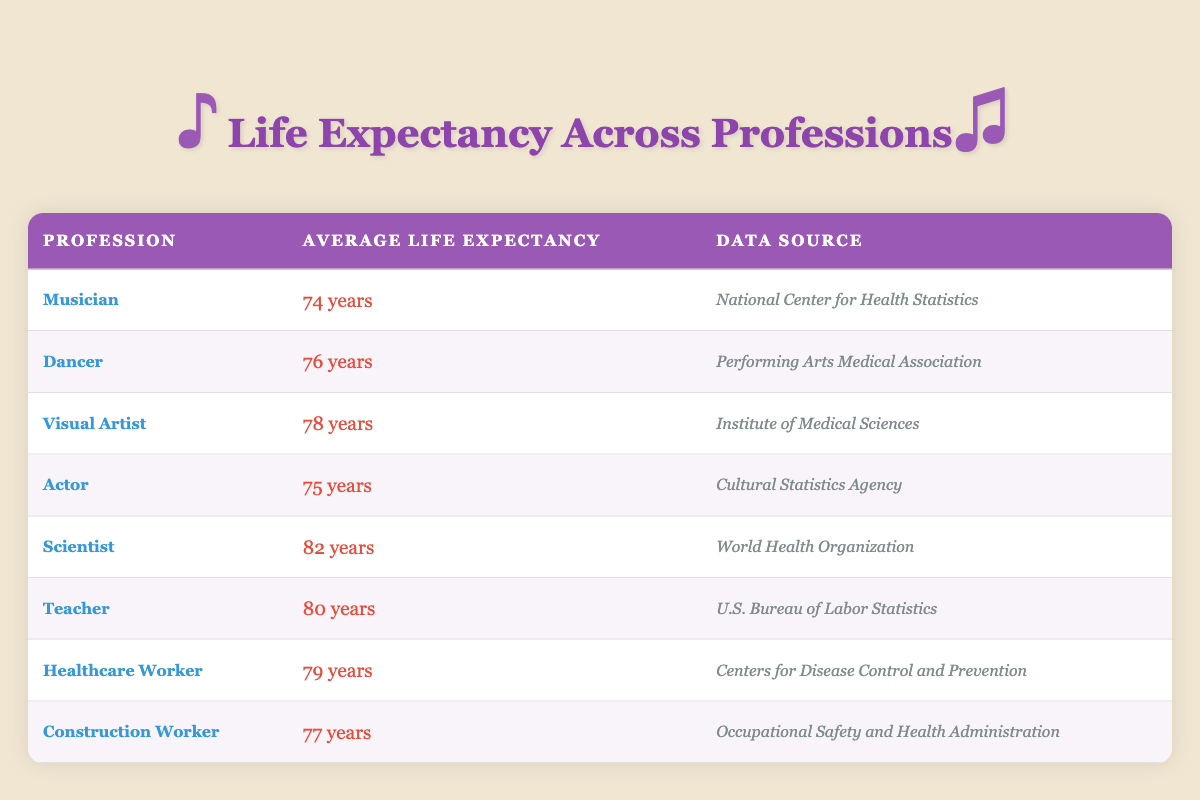What is the average life expectancy for dancers? The table lists the average life expectancy for dancers as 76 years. This information is found in the row corresponding to the profession "Dancer."
Answer: 76 years Which profession has the highest average life expectancy? Looking at the table, the profession with the highest average life expectancy is "Scientist," with an average life expectancy of 82 years.
Answer: Scientist Is the average life expectancy for musicians above 75 years? The table indicates that the average life expectancy for musicians is 74 years, which is below 75 years. Therefore, the answer is no.
Answer: No How much longer do visual artists live compared to musicians? The average life expectancy for visual artists is 78 years and for musicians, it is 74 years. To find the difference, subtract: 78 - 74 = 4 years.
Answer: 4 years Which performing arts profession has a longer life expectancy than the average for healthcare workers? The average life expectancy for healthcare workers is 79 years. Comparing this with the performing arts professions, "Dancer" (76 years), "Visual Artist" (78 years), and "Actor" (75 years) all have lower life expectancies than healthcare workers. None exceed 79 years. Therefore, no performing arts profession has a longer life expectancy.
Answer: None What is the average life expectancy of all professions listed in the table? To find the average, sum all life expectancies: 74 + 76 + 78 + 75 + 82 + 80 + 79 + 77 = 601. There are 8 professions, so divide the total by 8: 601 / 8 = 75.125. The approximate average life expectancy is 75 years when rounded.
Answer: 75 years Are teachers likely to live longer than musicians? The average life expectancy for teachers is 80 years and for musicians, it is 74 years. Since 80 is greater than 74, the answer is yes.
Answer: Yes Which profession has a shorter average life expectancy, construction workers or musicians? The table shows that construction workers have an average life expectancy of 77 years, while musicians have 74 years. Since 74 is less than 77, musicians have a shorter life expectancy.
Answer: Musicians 